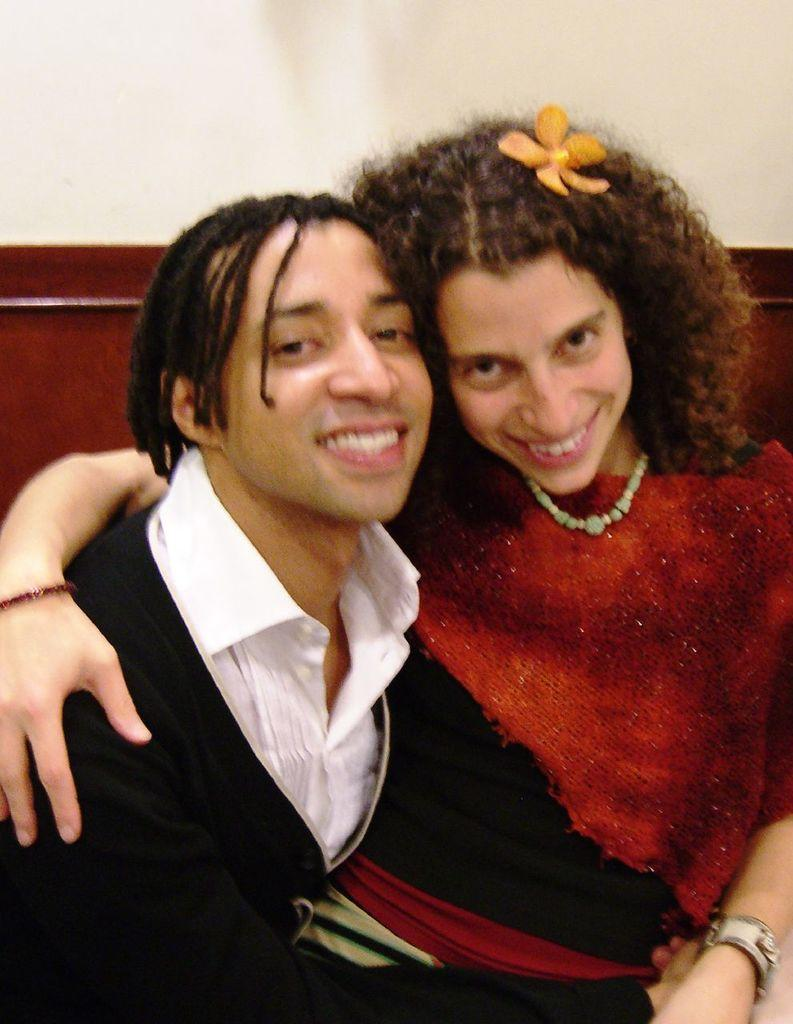How many people are present in the image? There are two people sitting in the image. What can be seen in the background of the image? There is a wall in the background of the image. Can you describe the wooden object in the image? There is a wooden object that looks like a board in the image. What type of collar can be seen on the wooden board in the image? There is no collar present in the image, as it features two people sitting and a wooden object that looks like a board. 